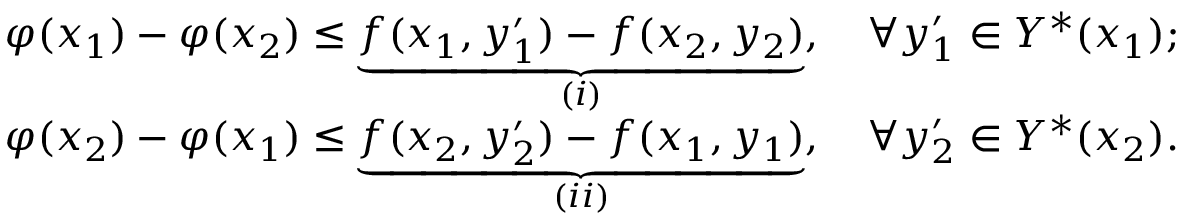Convert formula to latex. <formula><loc_0><loc_0><loc_500><loc_500>\begin{array} { r l } & { \varphi ( x _ { 1 } ) - \varphi ( x _ { 2 } ) \leq \underbrace { f ( x _ { 1 } , y _ { 1 } ^ { \prime } ) - f ( x _ { 2 } , y _ { 2 } ) } _ { ( i ) } , \quad \forall y _ { 1 } ^ { \prime } \in Y ^ { * } ( x _ { 1 } ) ; } \\ & { \varphi ( x _ { 2 } ) - \varphi ( x _ { 1 } ) \leq \underbrace { f ( x _ { 2 } , y _ { 2 } ^ { \prime } ) - f ( x _ { 1 } , y _ { 1 } ) } _ { ( i i ) } , \quad \forall y _ { 2 } ^ { \prime } \in Y ^ { * } ( x _ { 2 } ) . } \end{array}</formula> 